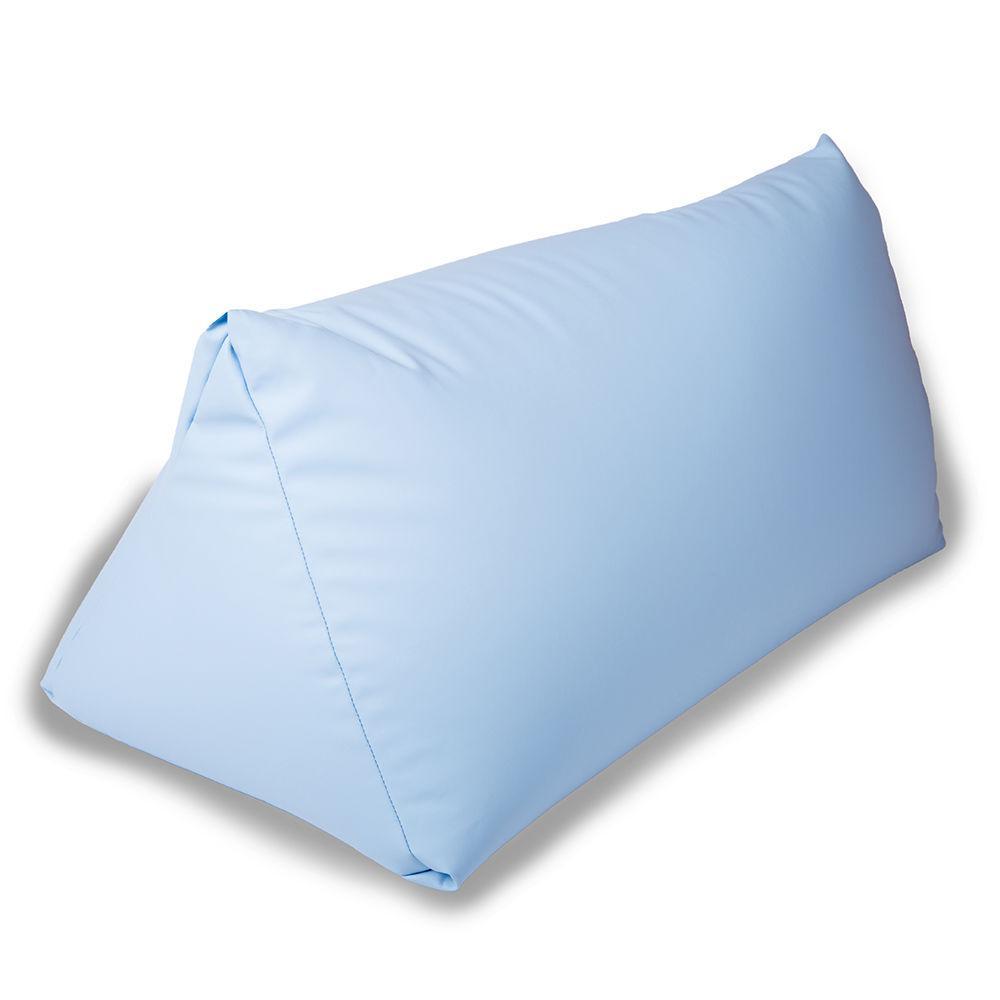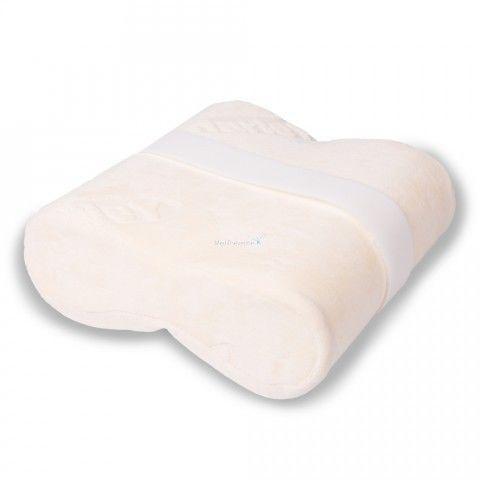The first image is the image on the left, the second image is the image on the right. For the images shown, is this caption "Some of the pillows mention spoons." true? Answer yes or no. No. 